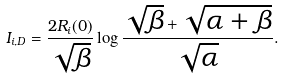Convert formula to latex. <formula><loc_0><loc_0><loc_500><loc_500>I _ { i , D } = \frac { 2 R _ { i } ( 0 ) } { \sqrt { \beta } } \log \frac { \sqrt { \beta } + \sqrt { \alpha + \beta } } { \sqrt { \alpha } } .</formula> 